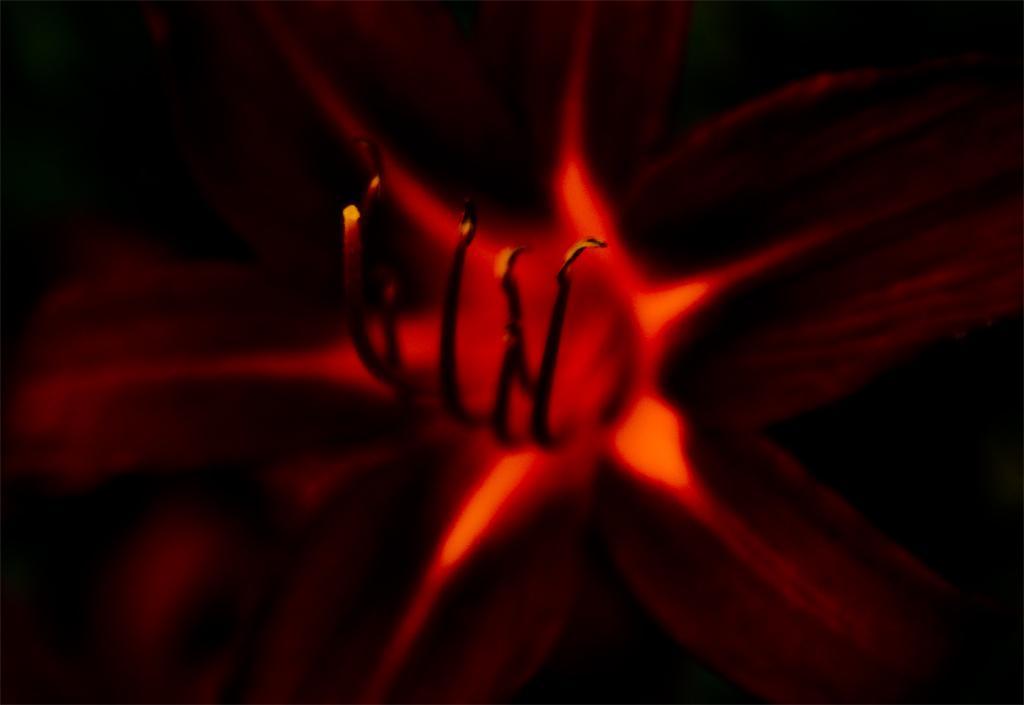Please provide a concise description of this image. In this image I can see a flower which is black, brown and red in color and I can see the black colored background. 